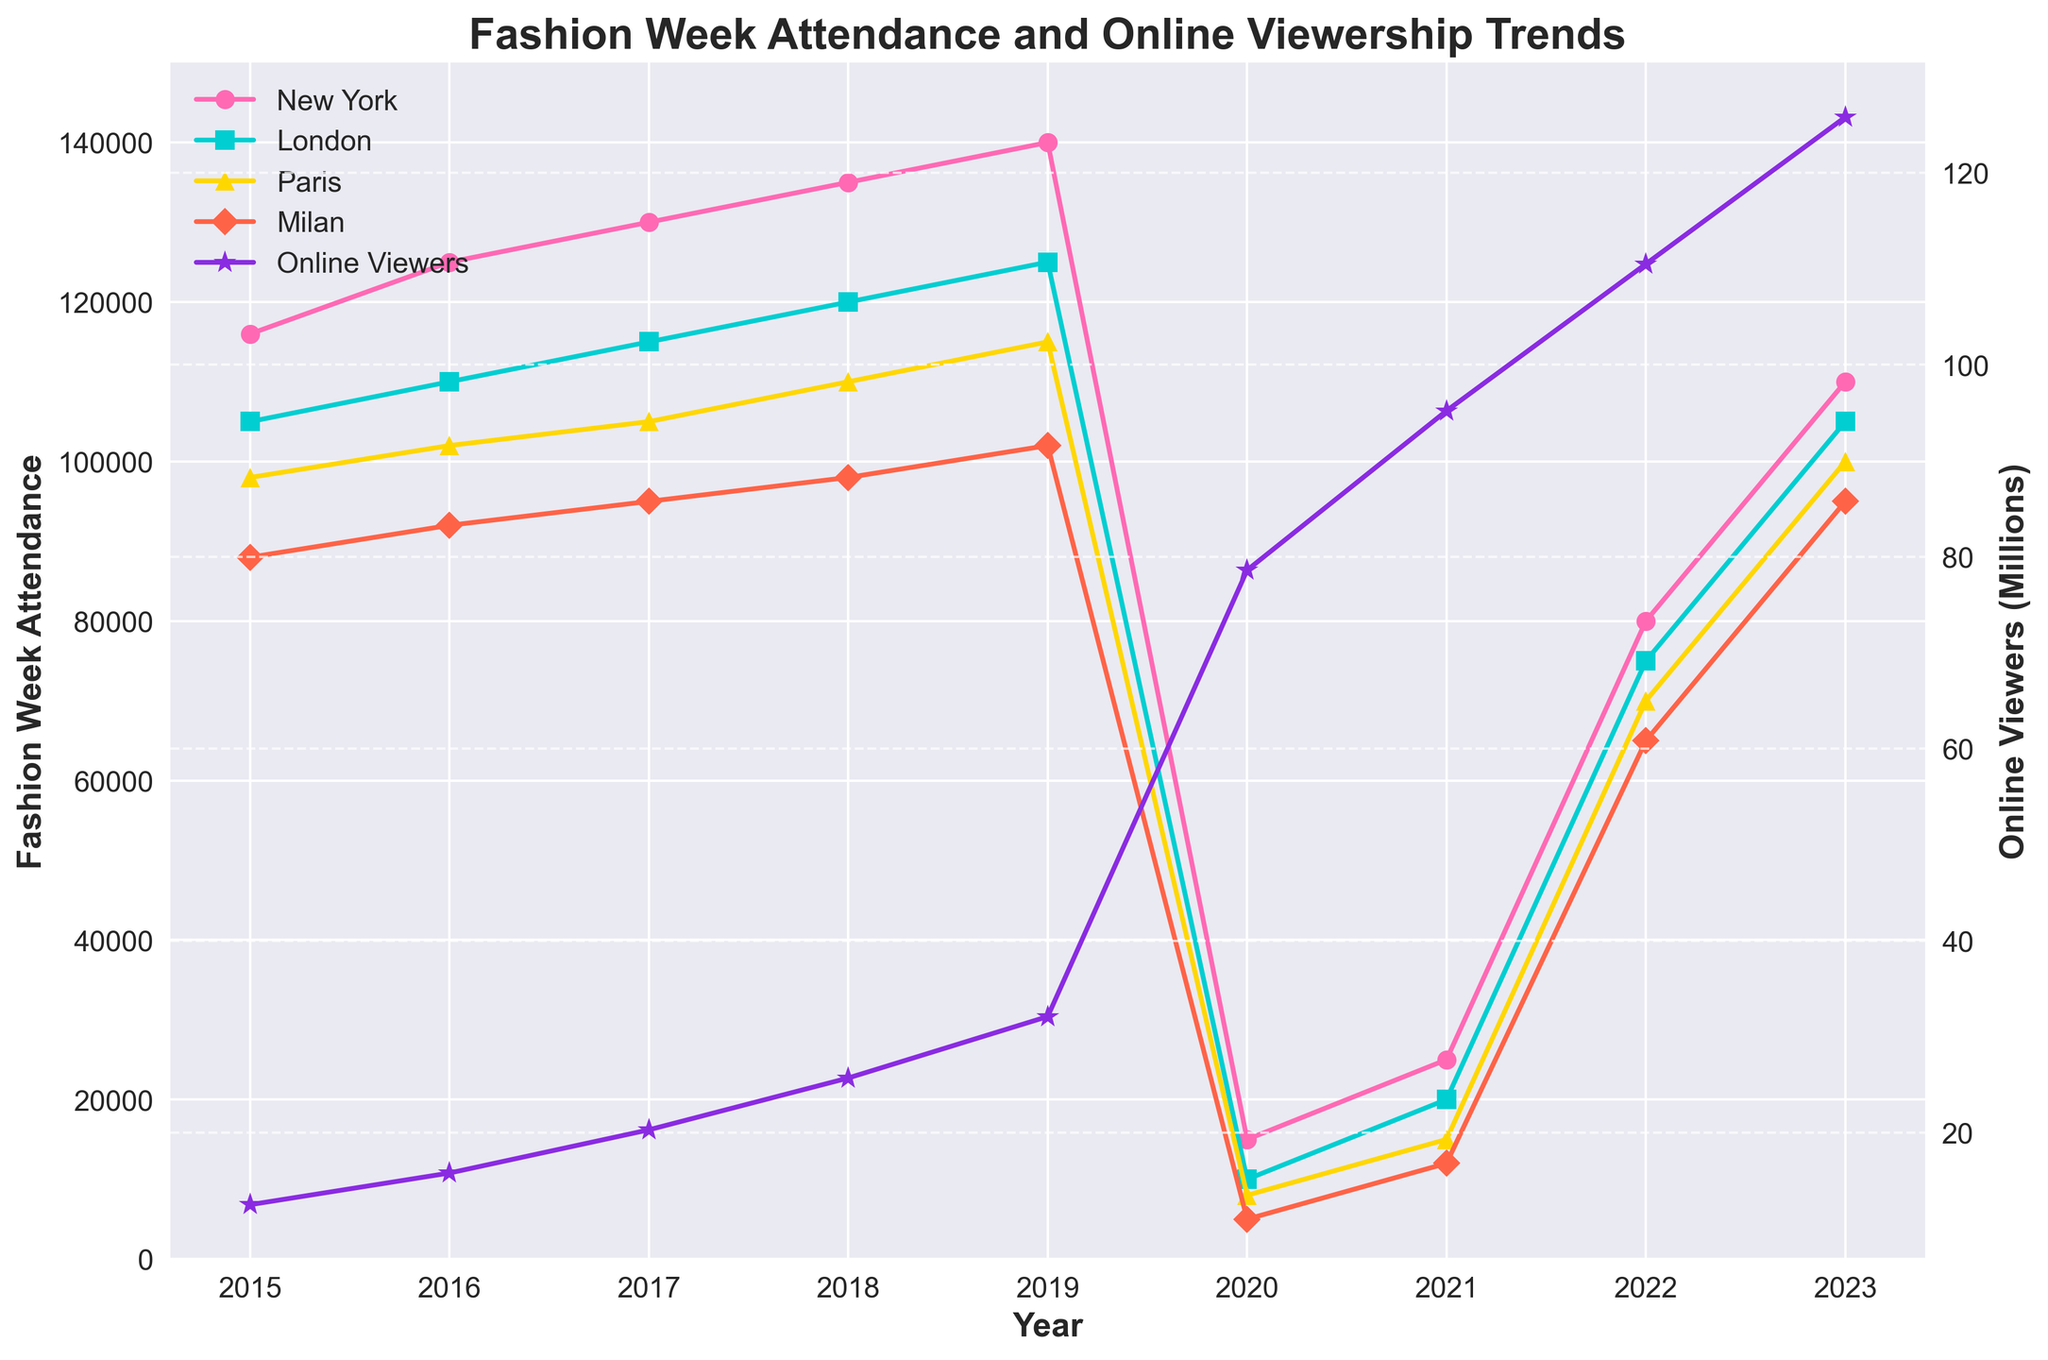What's the trend in online viewership from 2015 to 2023? The graph shows an increasing trend in online viewership, which goes from 12.5 million in 2015 to 125.8 million in 2023.
Answer: Increasing By how much did New York Fashion Week attendance change between 2019 and 2020? In 2019, the attendance was 140,000, and in 2020, it was 15,000. So, the change is 140,000 - 15,000 = 125,000.
Answer: 125,000 Which city had the least fashion week attendance in 2015? From the graph, Milan had the least attendance in 2015 with 88,000 attendees.
Answer: Milan How does the 2023 attendance in Paris compare to that in 2020? In 2020, Paris had 8,000 attendees, and in 2023, it had 100,000 attendees. So, the attendance in Paris increased significantly.
Answer: Increased significantly What has been the general trend in Milan's Fashion Week attendance from 2015 to 2023? From the graph, Milan's attendance shows a decreasing trend from 88,000 in 2015 to a low in 2020, then an increase again to 95,000 in 2023.
Answer: Decreasing then increasing What's the ratio of New York Fashion Week attendance to online viewership in 2016? In 2016, New York attendance was 125,000, and online viewership was 15.8 million. The ratio is 125,000 / 15,800,000.
Answer: 0.0079 Which year saw the maximum attendance for London Fashion Week? 2019 saw the maximum attendance for London Fashion Week with 125,000 attendees.
Answer: 2019 What was the difference in attendance between Paris and London in 2018? In 2018, Paris had 110,000 attendees, and London had 120,000 attendees. The difference is 120,000 - 110,000 = 10,000.
Answer: 10,000 In 2021, which had a greater increase compared to the previous year: Milan’s attendance or online viewership? Milan's attendance increased from 5,000 to 12,000 (a 7,000 increase), while online viewership increased from 78.6 million to 95.2 million (a 16.6 million increase). Online viewership had a greater increase.
Answer: Online viewership What visual element is used to represent online viewership? Online viewership is represented by a purple line with star-shaped markers.
Answer: Purple line with star markers 